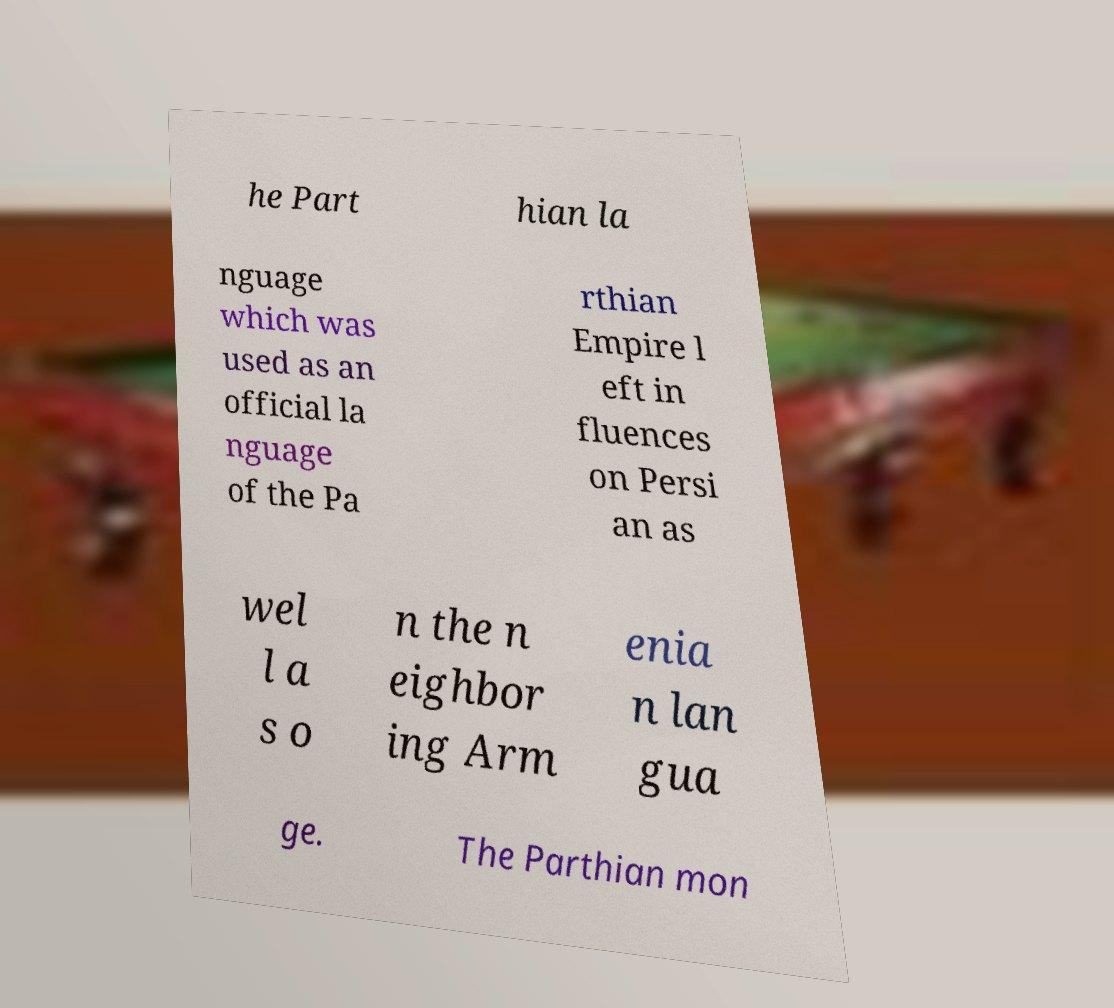Can you accurately transcribe the text from the provided image for me? he Part hian la nguage which was used as an official la nguage of the Pa rthian Empire l eft in fluences on Persi an as wel l a s o n the n eighbor ing Arm enia n lan gua ge. The Parthian mon 